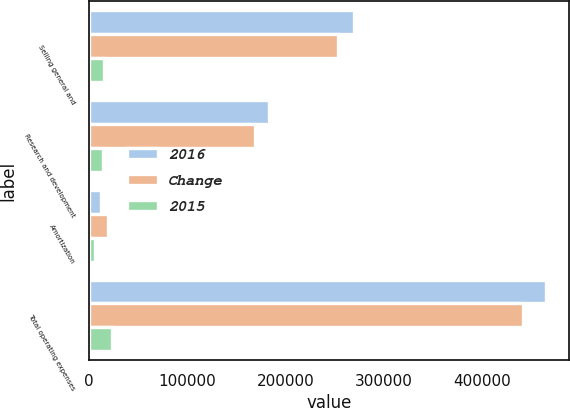<chart> <loc_0><loc_0><loc_500><loc_500><stacked_bar_chart><ecel><fcel>Selling general and<fcel>Research and development<fcel>Amortization<fcel>Total operating expenses<nl><fcel>2016<fcel>269515<fcel>183093<fcel>12755<fcel>465363<nl><fcel>Change<fcel>253603<fcel>168831<fcel>19394<fcel>441828<nl><fcel>2015<fcel>15912<fcel>14262<fcel>6639<fcel>23535<nl></chart> 